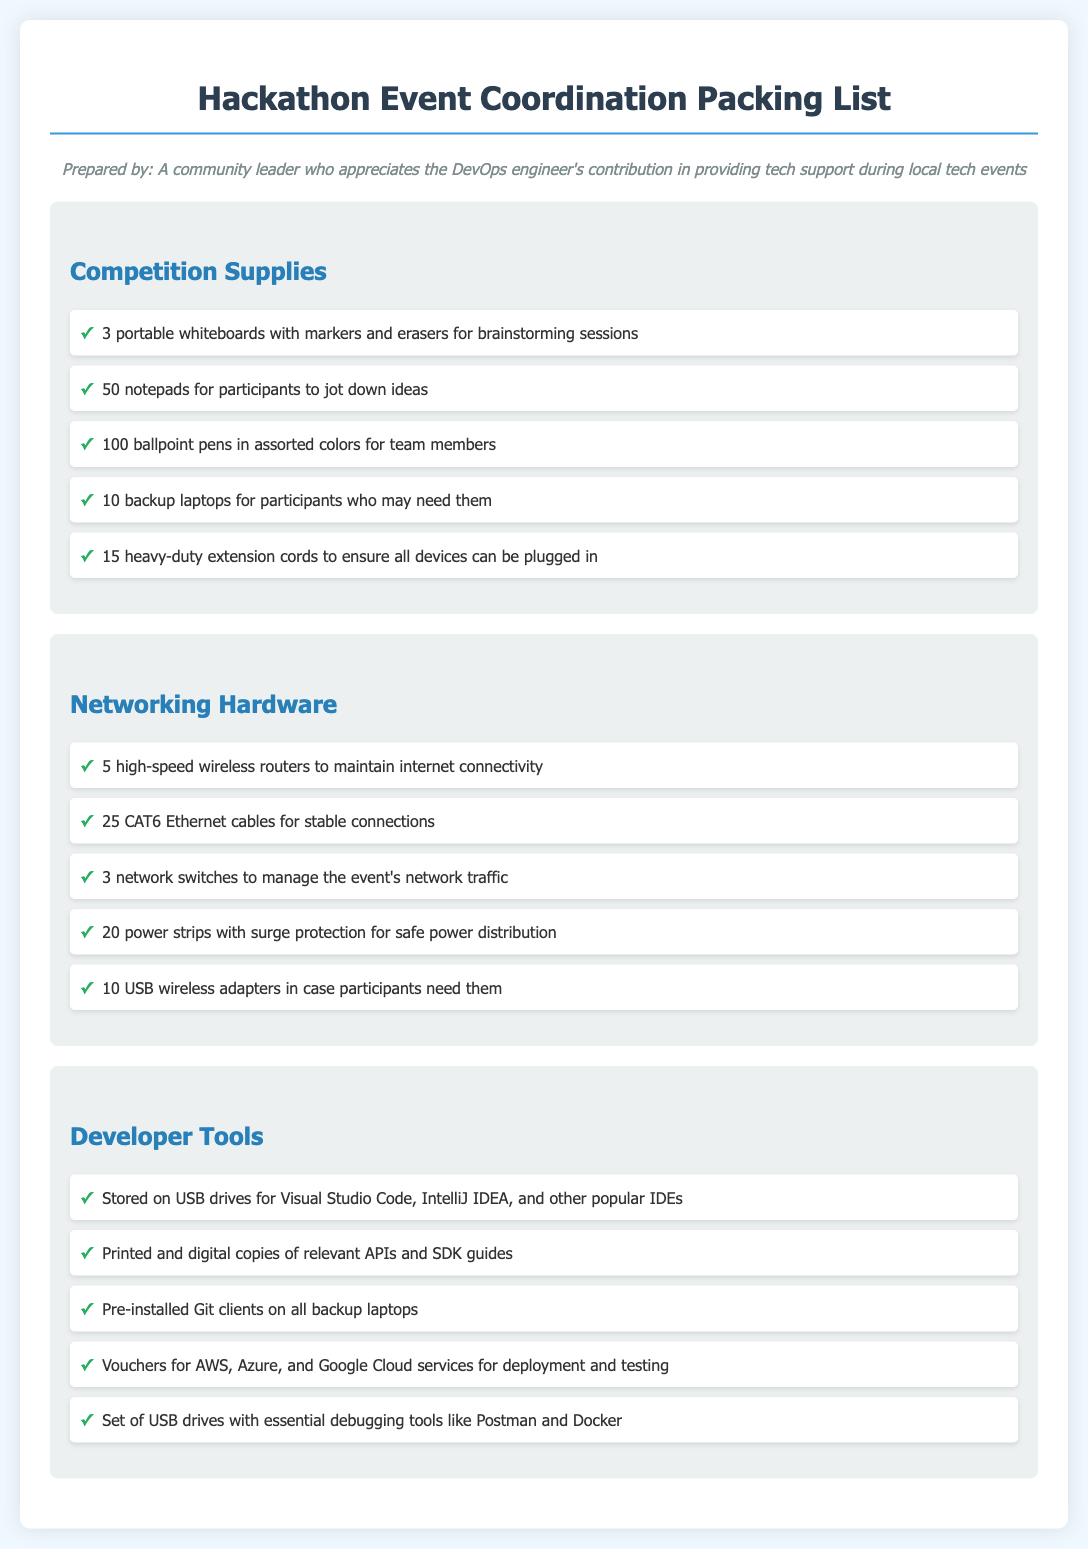What items are listed under Competition Supplies? The document includes specific items like portable whiteboards and notepads under the Competition Supplies section.
Answer: 3 portable whiteboards, 50 notepads, 100 ballpoint pens, 10 backup laptops, 15 heavy-duty extension cords How many high-speed wireless routers are needed? The document states that 5 high-speed wireless routers are required for maintaining internet connectivity at the event.
Answer: 5 What is one type of developer tool mentioned? The document lists various developer tools, including IDEs, USB drives, and vouchers.
Answer: Visual Studio Code How many CAT6 Ethernet cables are required? The document specifies the need for 25 CAT6 Ethernet cables to provide stable connections.
Answer: 25 What are the total types of items mentioned in the Networking Hardware section? The Networking Hardware section includes a total of 5 listed items, indicating the comprehensive needs for networking at the event.
Answer: 5 Why are USB wireless adapters included? The document mentions USB wireless adapters to accommodate participants who might require them during the event.
Answer: In case participants need them What is the purpose of heavy-duty extension cords? The document states that heavy-duty extension cords are included to ensure that all devices can be plugged in during the event.
Answer: To ensure all devices can be plugged in How many printed copies of APIs and SDK guides are provided? The document indicates that printed and digital copies of relevant APIs and SDK guides are available but does not specify a number.
Answer: Not specified What type of power protection is mentioned for power strips? The document mentions that power strips included will have surge protection for safe power distribution.
Answer: Surge protection 